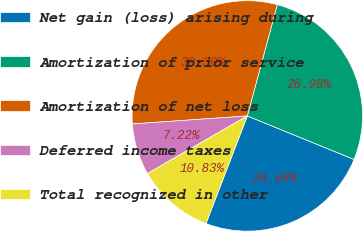Convert chart. <chart><loc_0><loc_0><loc_500><loc_500><pie_chart><fcel>Net gain (loss) arising during<fcel>Amortization of prior service<fcel>Amortization of net loss<fcel>Deferred income taxes<fcel>Total recognized in other<nl><fcel>24.68%<fcel>26.98%<fcel>30.3%<fcel>7.22%<fcel>10.83%<nl></chart> 